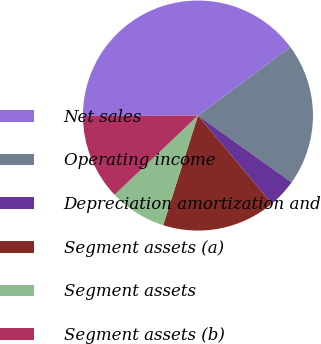Convert chart. <chart><loc_0><loc_0><loc_500><loc_500><pie_chart><fcel>Net sales<fcel>Operating income<fcel>Depreciation amortization and<fcel>Segment assets (a)<fcel>Segment assets<fcel>Segment assets (b)<nl><fcel>39.96%<fcel>19.99%<fcel>4.02%<fcel>16.0%<fcel>8.02%<fcel>12.01%<nl></chart> 